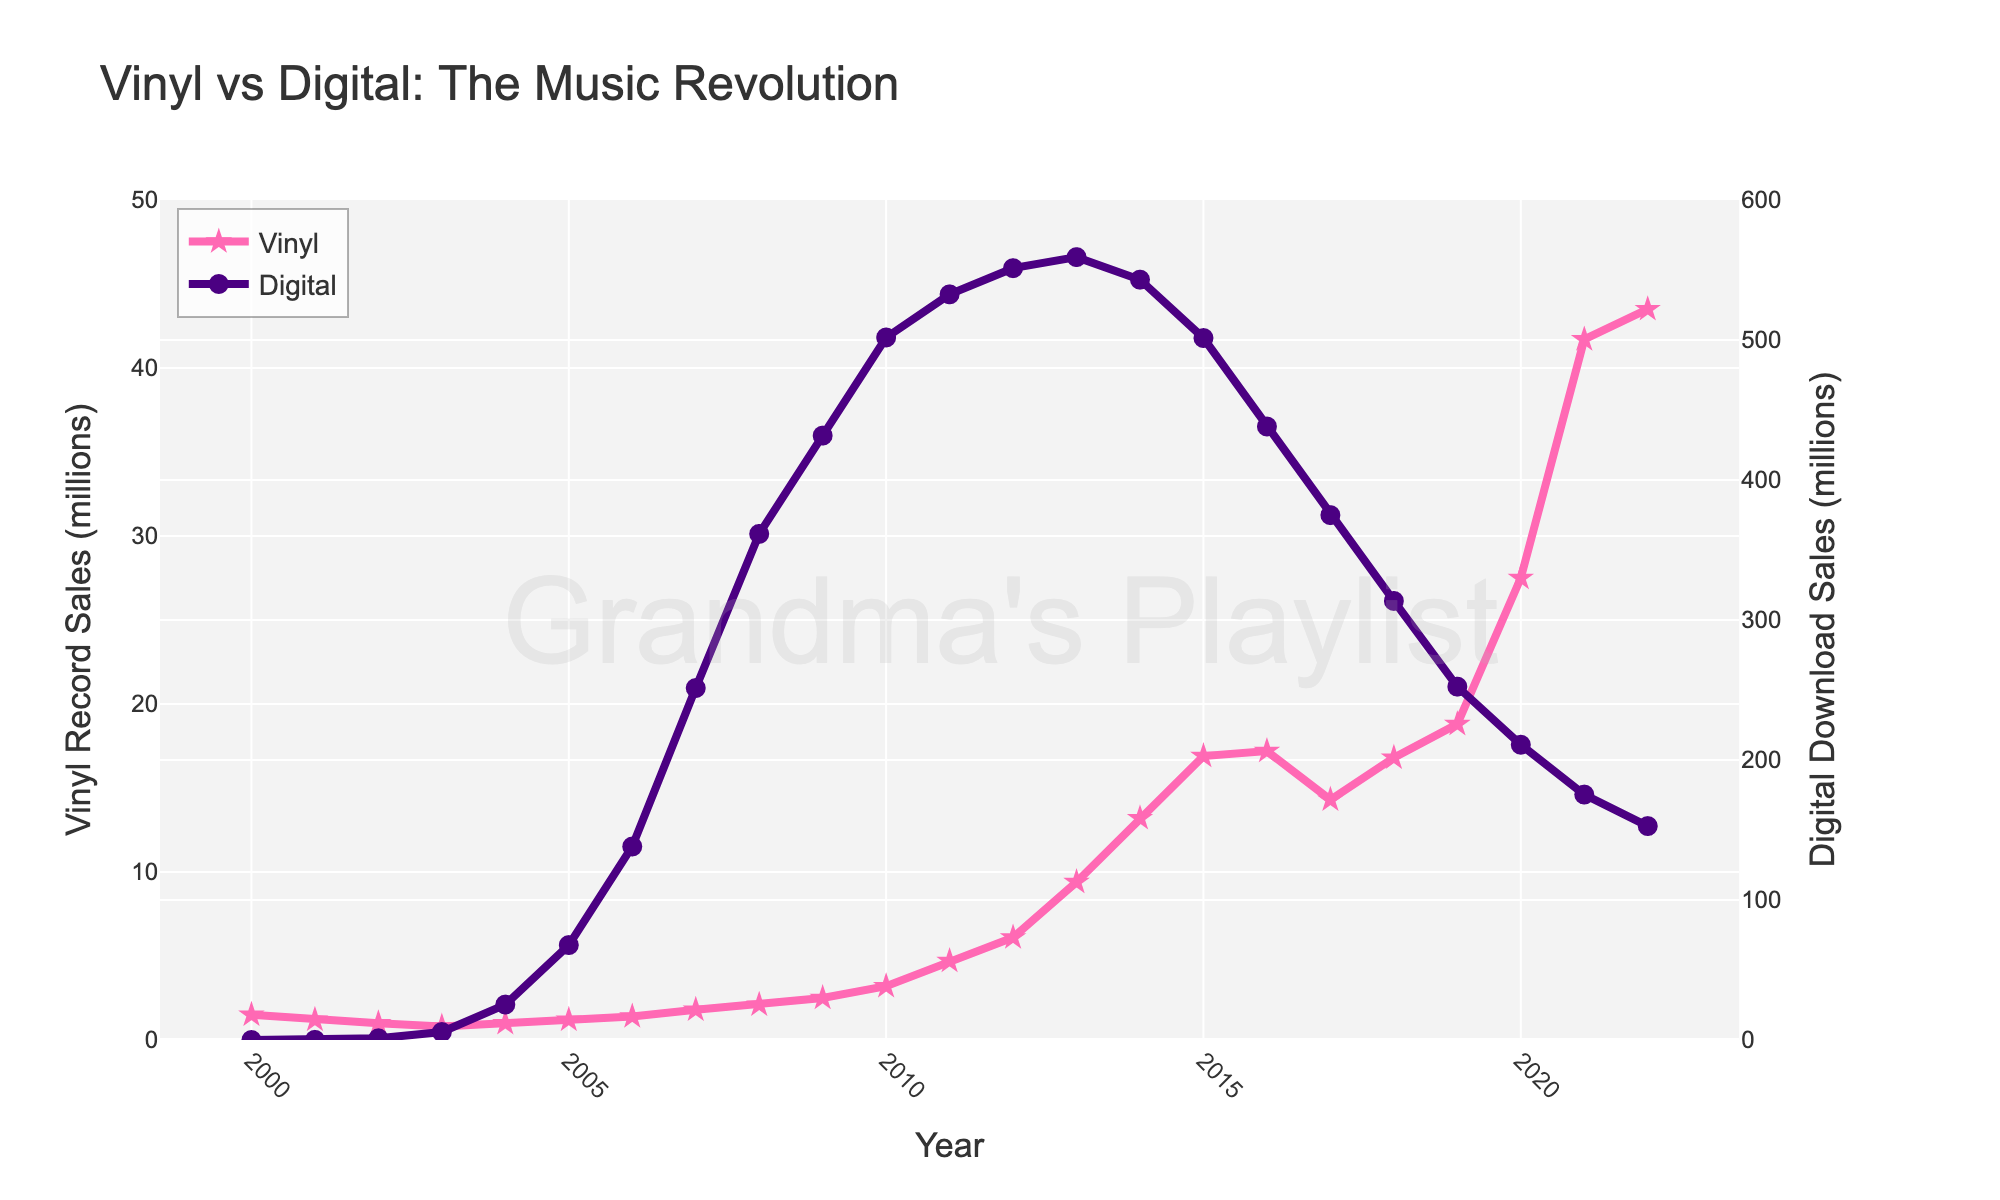Which year had the highest vinyl record sales? To determine the year with the highest vinyl record sales, locate the peak point on the pink line (vinyl record sales). According to the plot, the highest value is around 2022.
Answer: 2022 Compare vinyl record sales between 2010 and 2020. Which year had more sales? Locate 2010 and 2020 on the pink line and compare their values. The sales in 2010 were 3.2 million, and in 2020, it was 27.5 million.
Answer: 2020 By how much did digital download sales decrease from their peak in 2013 to 2022? Locate the peak value of digital download sales in 2013, which is around 559.2 million, then locate the value in 2022, which is around 152.8 million. Subtract the 2022 value from the 2013 peak value: 559.2 - 152.8 = 406.4 million.
Answer: 406.4 million What color represents digital download sales on the chart? Look at the legend on the chart to identify the color associated with digital download sales. It is represented by a purple line.
Answer: Purple How do vinyl record sales in 2000 compare to those in 2022? Locate the values of vinyl record sales in 2000 and 2022 on the pink line. The sales in 2000 were 1.5 million, and in 2022, they were 43.5 million. Vinyl record sales in 2022 are significantly higher than in 2000.
Answer: Higher in 2022 Which year shows the smallest gap between vinyl record sales and digital download sales? To find the smallest gap, visually compare the two lines year by year and estimate the difference. The smallest gap seems to occur around 2000 when both digital sales were 0 and vinyl sales were low at 1.5 million.
Answer: 2000 When did digital download sales first surpass vinyl record sales? Look for the first intersection between the pink and purple lines. Digital download sales first surpassed vinyl record sales between 2002 and 2003.
Answer: Between 2002 and 2003 What can be noticed about the trend of digital download sales from 2013 onwards? Track the trajectory of the purple line from 2013; it generally decreases continuously over the following years until 2022.
Answer: Decreasing trend Are there any years where both vinyl record sales and digital download sales increased compared to the previous year? Analyze both lines and track years where both see an increase. Both sales increased in years like 2005 and 2006.
Answer: 2005, 2006 What's the average digital download sales from 2018 to 2022? Sum up the digital download sales values for each year from 2018 to 2022: (313.6 + 252.4 + 210.9 + 175.3 + 152.8) = 1105. Divide by the number of years (5): 1105 / 5 = 221
Answer: 221 